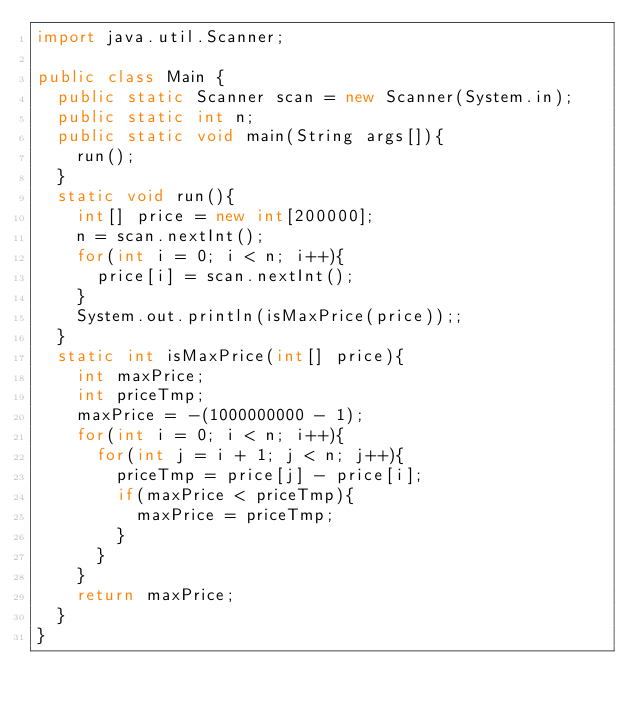<code> <loc_0><loc_0><loc_500><loc_500><_Java_>import java.util.Scanner;

public class Main {
	public static Scanner scan = new Scanner(System.in);
	public static int n;
	public static void main(String args[]){
		run();
	}
	static void run(){
		int[] price = new int[200000];
		n = scan.nextInt();
		for(int i = 0; i < n; i++){
			price[i] = scan.nextInt();
		}
		System.out.println(isMaxPrice(price));;
	}
	static int isMaxPrice(int[] price){
		int maxPrice;
		int priceTmp;
		maxPrice = -(1000000000 - 1);
		for(int i = 0; i < n; i++){
			for(int j = i + 1; j < n; j++){
				priceTmp = price[j] - price[i];
				if(maxPrice < priceTmp){
					maxPrice = priceTmp;
				}
			}
		}
		return maxPrice;
	}
}</code> 